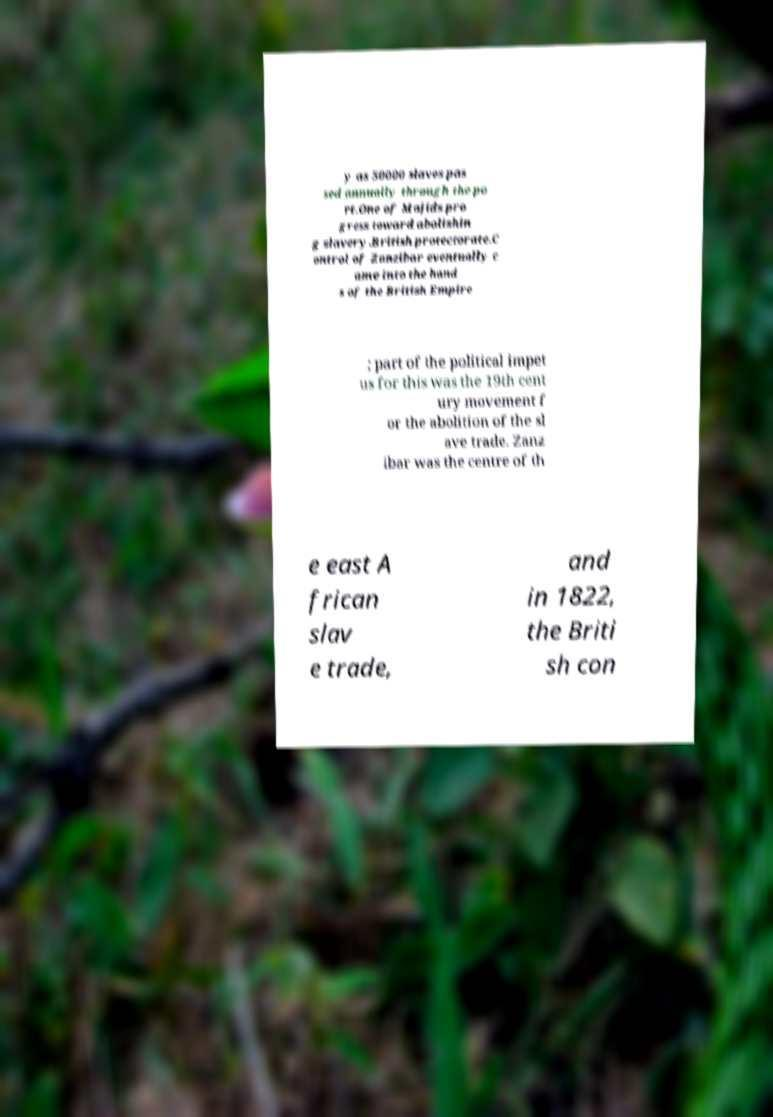For documentation purposes, I need the text within this image transcribed. Could you provide that? y as 50000 slaves pas sed annually through the po rt.One of Majids pro gress toward abolishin g slavery.British protectorate.C ontrol of Zanzibar eventually c ame into the hand s of the British Empire ; part of the political impet us for this was the 19th cent ury movement f or the abolition of the sl ave trade. Zanz ibar was the centre of th e east A frican slav e trade, and in 1822, the Briti sh con 